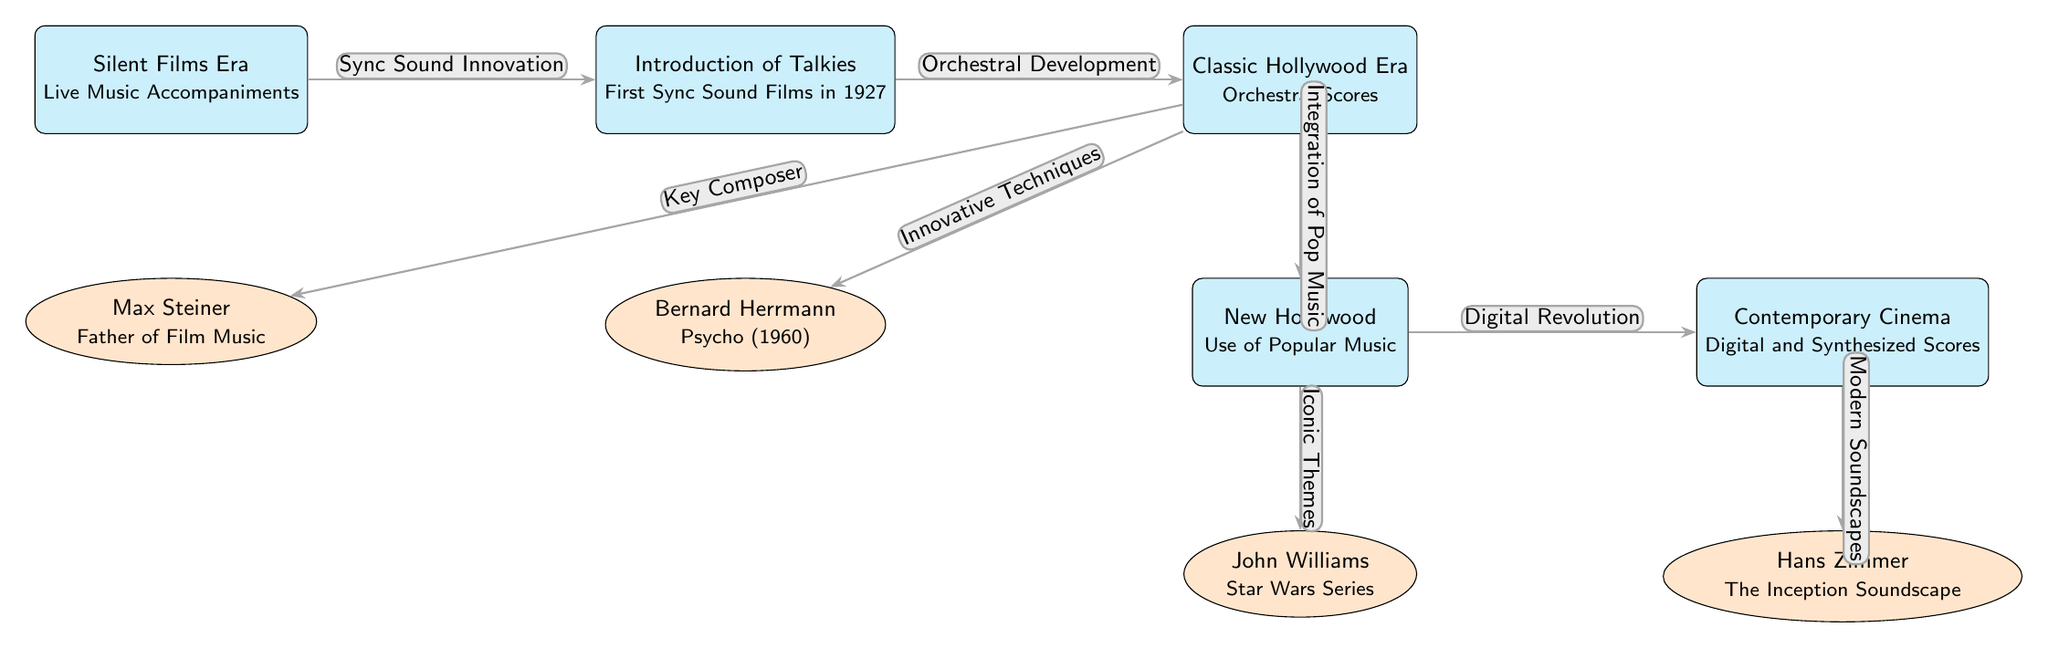What is the first era depicted in this diagram? The diagram starts with the "Silent Films Era," which is positioned on the far left as the initial stage in the evolution of film scoring techniques.
Answer: Silent Films Era Who is associated with the “Contemporary Cinema” era? The diagram indicates Hans Zimmer as the composer linked to the "Contemporary Cinema" era, which illustrates the digital and synthesized scores characteristic of modern films.
Answer: Hans Zimmer What innovation connects the “Silent Films Era” to the “Introduction of Talkies”? The diagram specifies "Sync Sound Innovation" as the connection between these two eras, emphasizing a pivotal shift in film scoring techniques as synchronized sound was introduced.
Answer: Sync Sound Innovation How many key composers are identified in the diagram? After counting the composer nodes represented below the eras, there are four key composers listed: Max Steiner, Bernard Herrmann, John Williams, and Hans Zimmer.
Answer: Four What is the relationship type between the “Classic Hollywood Era” and “New Hollywood”? The diagram shows that the relationship between the "Classic Hollywood Era" and "New Hollywood" is represented as "Integration of Pop Music," indicating a transition where popular music began to play a more significant role in film scoring.
Answer: Integration of Pop Music Which composer is associated with iconic themes in the New Hollywood era? The diagram identifies John Williams as the composer connected with "Iconic Themes" in the New Hollywood era, highlighting his contribution to memorable film scores such as those in the Star Wars series.
Answer: John Williams What does the arrow labeled “Digital Revolution” signify? The arrow labeled "Digital Revolution" shows the transition from "New Hollywood," which used popular music, to "Contemporary Cinema," where digital and synthesized scores became prevalent, demonstrating technological advancement in film scoring.
Answer: Digital Revolution Which innovation marks the transition from "Introduction of Talkies" to "Classic Hollywood Era"? According to the diagram, "Orchestral Development" is the key innovation that signifies the evolution from the synchronized sound of talkies to the orchestral scores characteristic of the Classic Hollywood Era.
Answer: Orchestral Development What type of scores are noted under the “Contemporary Cinema”? The diagram explicitly mentions "Digital and Synthesized Scores" as defining characteristics of the "Contemporary Cinema" era, showcasing the modern approaches to film scoring.
Answer: Digital and Synthesized Scores 